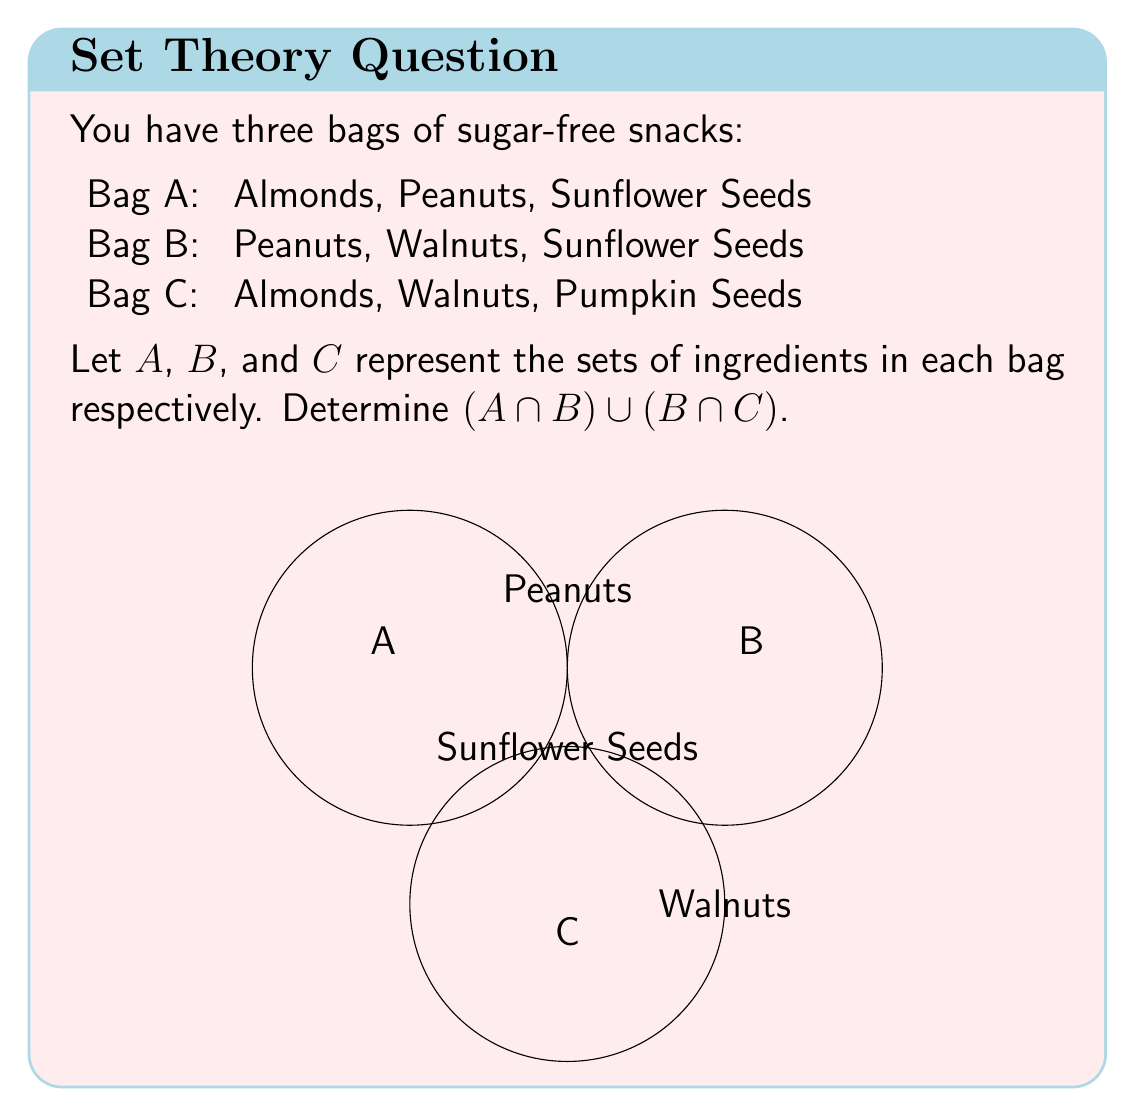Solve this math problem. Let's approach this step-by-step:

1) First, let's define our sets:
   $A = \{Almonds, Peanuts, Sunflower Seeds\}$
   $B = \{Peanuts, Walnuts, Sunflower Seeds\}$
   $C = \{Almonds, Walnuts, Pumpkin Seeds\}$

2) We need to find $(A \cap B) \cup (B \cap C)$

3) Let's start with $A \cap B$:
   $A \cap B = \{Peanuts, Sunflower Seeds\}$

4) Next, let's find $B \cap C$:
   $B \cap C = \{Walnuts\}$

5) Now, we need to find the union of these two intersections:
   $(A \cap B) \cup (B \cap C) = \{Peanuts, Sunflower Seeds\} \cup \{Walnuts\}$

6) The union of these sets gives us all unique elements:
   $(A \cap B) \cup (B \cap C) = \{Peanuts, Sunflower Seeds, Walnuts\}$

This result represents all ingredients that are common to at least two of the three bags.
Answer: $\{Peanuts, Sunflower Seeds, Walnuts\}$ 